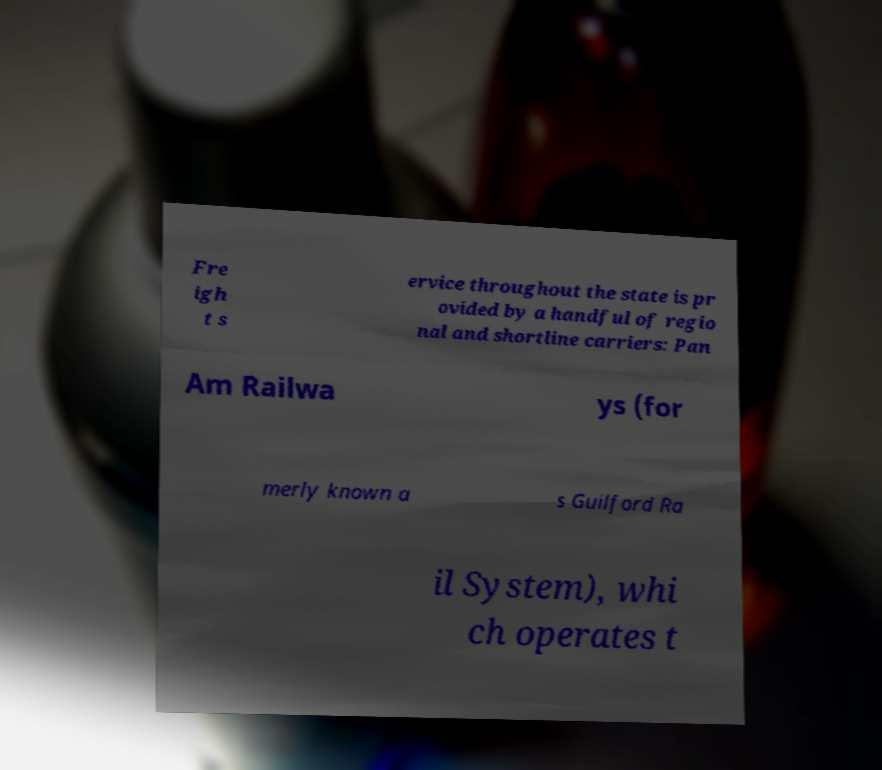There's text embedded in this image that I need extracted. Can you transcribe it verbatim? Fre igh t s ervice throughout the state is pr ovided by a handful of regio nal and shortline carriers: Pan Am Railwa ys (for merly known a s Guilford Ra il System), whi ch operates t 